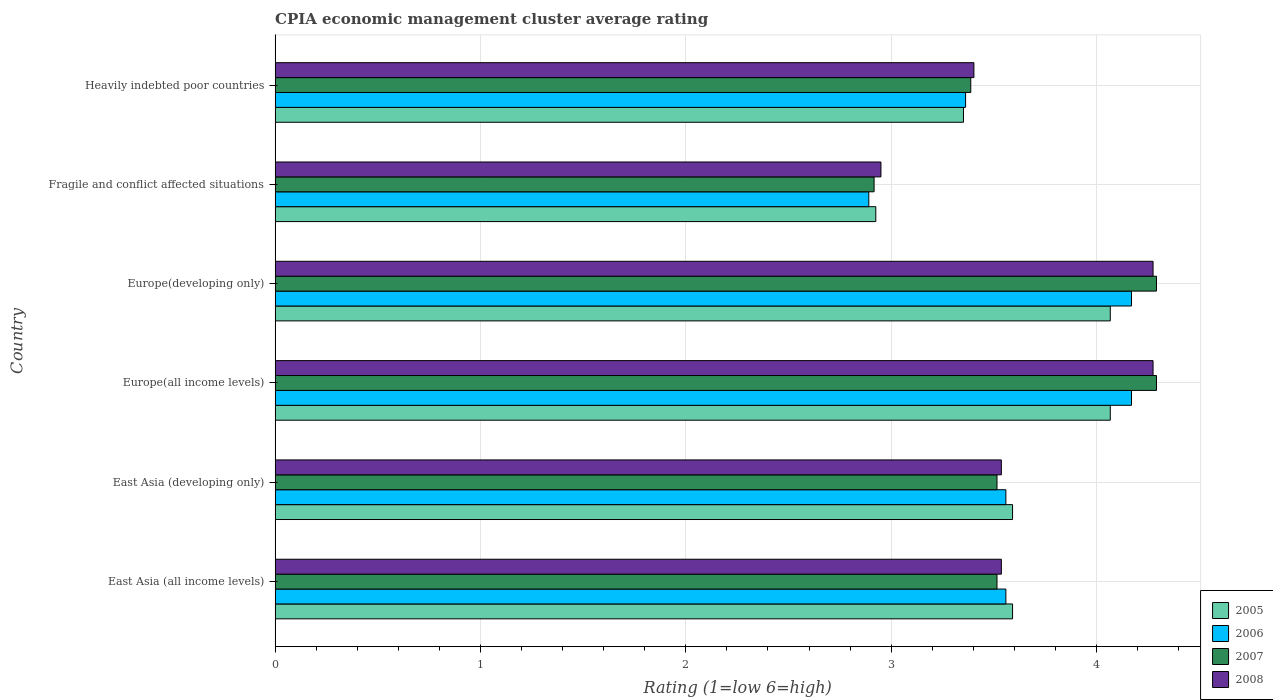How many groups of bars are there?
Offer a very short reply. 6. Are the number of bars per tick equal to the number of legend labels?
Provide a succinct answer. Yes. Are the number of bars on each tick of the Y-axis equal?
Provide a short and direct response. Yes. How many bars are there on the 1st tick from the bottom?
Keep it short and to the point. 4. What is the label of the 6th group of bars from the top?
Give a very brief answer. East Asia (all income levels). In how many cases, is the number of bars for a given country not equal to the number of legend labels?
Give a very brief answer. 0. What is the CPIA rating in 2008 in Fragile and conflict affected situations?
Make the answer very short. 2.95. Across all countries, what is the maximum CPIA rating in 2008?
Offer a terse response. 4.28. Across all countries, what is the minimum CPIA rating in 2005?
Provide a succinct answer. 2.92. In which country was the CPIA rating in 2006 maximum?
Offer a terse response. Europe(all income levels). In which country was the CPIA rating in 2008 minimum?
Provide a succinct answer. Fragile and conflict affected situations. What is the total CPIA rating in 2008 in the graph?
Give a very brief answer. 21.98. What is the difference between the CPIA rating in 2007 in East Asia (all income levels) and that in Fragile and conflict affected situations?
Your answer should be compact. 0.6. What is the difference between the CPIA rating in 2005 in Heavily indebted poor countries and the CPIA rating in 2006 in East Asia (developing only)?
Ensure brevity in your answer.  -0.21. What is the average CPIA rating in 2007 per country?
Your response must be concise. 3.65. What is the difference between the CPIA rating in 2008 and CPIA rating in 2007 in Europe(all income levels)?
Make the answer very short. -0.02. In how many countries, is the CPIA rating in 2005 greater than 2.6 ?
Your answer should be very brief. 6. What is the ratio of the CPIA rating in 2007 in East Asia (all income levels) to that in Heavily indebted poor countries?
Provide a succinct answer. 1.04. Is the CPIA rating in 2007 in East Asia (all income levels) less than that in Fragile and conflict affected situations?
Provide a succinct answer. No. What is the difference between the highest and the lowest CPIA rating in 2005?
Your answer should be compact. 1.14. What does the 1st bar from the top in Heavily indebted poor countries represents?
Offer a terse response. 2008. Is it the case that in every country, the sum of the CPIA rating in 2007 and CPIA rating in 2005 is greater than the CPIA rating in 2006?
Provide a succinct answer. Yes. Are all the bars in the graph horizontal?
Offer a terse response. Yes. How many countries are there in the graph?
Your answer should be very brief. 6. Does the graph contain any zero values?
Keep it short and to the point. No. Where does the legend appear in the graph?
Give a very brief answer. Bottom right. How are the legend labels stacked?
Offer a terse response. Vertical. What is the title of the graph?
Your answer should be compact. CPIA economic management cluster average rating. What is the Rating (1=low 6=high) of 2005 in East Asia (all income levels)?
Give a very brief answer. 3.59. What is the Rating (1=low 6=high) of 2006 in East Asia (all income levels)?
Make the answer very short. 3.56. What is the Rating (1=low 6=high) in 2007 in East Asia (all income levels)?
Give a very brief answer. 3.52. What is the Rating (1=low 6=high) of 2008 in East Asia (all income levels)?
Ensure brevity in your answer.  3.54. What is the Rating (1=low 6=high) in 2005 in East Asia (developing only)?
Your answer should be compact. 3.59. What is the Rating (1=low 6=high) of 2006 in East Asia (developing only)?
Your answer should be very brief. 3.56. What is the Rating (1=low 6=high) in 2007 in East Asia (developing only)?
Make the answer very short. 3.52. What is the Rating (1=low 6=high) of 2008 in East Asia (developing only)?
Your answer should be very brief. 3.54. What is the Rating (1=low 6=high) in 2005 in Europe(all income levels)?
Ensure brevity in your answer.  4.07. What is the Rating (1=low 6=high) in 2006 in Europe(all income levels)?
Provide a short and direct response. 4.17. What is the Rating (1=low 6=high) in 2007 in Europe(all income levels)?
Your response must be concise. 4.29. What is the Rating (1=low 6=high) in 2008 in Europe(all income levels)?
Offer a very short reply. 4.28. What is the Rating (1=low 6=high) of 2005 in Europe(developing only)?
Keep it short and to the point. 4.07. What is the Rating (1=low 6=high) in 2006 in Europe(developing only)?
Keep it short and to the point. 4.17. What is the Rating (1=low 6=high) of 2007 in Europe(developing only)?
Your answer should be very brief. 4.29. What is the Rating (1=low 6=high) in 2008 in Europe(developing only)?
Offer a terse response. 4.28. What is the Rating (1=low 6=high) in 2005 in Fragile and conflict affected situations?
Keep it short and to the point. 2.92. What is the Rating (1=low 6=high) in 2006 in Fragile and conflict affected situations?
Your answer should be compact. 2.89. What is the Rating (1=low 6=high) in 2007 in Fragile and conflict affected situations?
Offer a terse response. 2.92. What is the Rating (1=low 6=high) in 2008 in Fragile and conflict affected situations?
Ensure brevity in your answer.  2.95. What is the Rating (1=low 6=high) in 2005 in Heavily indebted poor countries?
Ensure brevity in your answer.  3.35. What is the Rating (1=low 6=high) in 2006 in Heavily indebted poor countries?
Make the answer very short. 3.36. What is the Rating (1=low 6=high) of 2007 in Heavily indebted poor countries?
Keep it short and to the point. 3.39. What is the Rating (1=low 6=high) in 2008 in Heavily indebted poor countries?
Make the answer very short. 3.4. Across all countries, what is the maximum Rating (1=low 6=high) of 2005?
Give a very brief answer. 4.07. Across all countries, what is the maximum Rating (1=low 6=high) of 2006?
Make the answer very short. 4.17. Across all countries, what is the maximum Rating (1=low 6=high) in 2007?
Your response must be concise. 4.29. Across all countries, what is the maximum Rating (1=low 6=high) of 2008?
Provide a succinct answer. 4.28. Across all countries, what is the minimum Rating (1=low 6=high) of 2005?
Keep it short and to the point. 2.92. Across all countries, what is the minimum Rating (1=low 6=high) in 2006?
Keep it short and to the point. 2.89. Across all countries, what is the minimum Rating (1=low 6=high) of 2007?
Offer a terse response. 2.92. Across all countries, what is the minimum Rating (1=low 6=high) in 2008?
Your answer should be very brief. 2.95. What is the total Rating (1=low 6=high) of 2005 in the graph?
Give a very brief answer. 21.59. What is the total Rating (1=low 6=high) of 2006 in the graph?
Provide a succinct answer. 21.71. What is the total Rating (1=low 6=high) of 2007 in the graph?
Offer a very short reply. 21.92. What is the total Rating (1=low 6=high) of 2008 in the graph?
Provide a short and direct response. 21.98. What is the difference between the Rating (1=low 6=high) in 2007 in East Asia (all income levels) and that in East Asia (developing only)?
Keep it short and to the point. 0. What is the difference between the Rating (1=low 6=high) of 2005 in East Asia (all income levels) and that in Europe(all income levels)?
Your response must be concise. -0.48. What is the difference between the Rating (1=low 6=high) in 2006 in East Asia (all income levels) and that in Europe(all income levels)?
Provide a short and direct response. -0.61. What is the difference between the Rating (1=low 6=high) in 2007 in East Asia (all income levels) and that in Europe(all income levels)?
Keep it short and to the point. -0.78. What is the difference between the Rating (1=low 6=high) of 2008 in East Asia (all income levels) and that in Europe(all income levels)?
Give a very brief answer. -0.74. What is the difference between the Rating (1=low 6=high) in 2005 in East Asia (all income levels) and that in Europe(developing only)?
Provide a succinct answer. -0.48. What is the difference between the Rating (1=low 6=high) of 2006 in East Asia (all income levels) and that in Europe(developing only)?
Offer a very short reply. -0.61. What is the difference between the Rating (1=low 6=high) of 2007 in East Asia (all income levels) and that in Europe(developing only)?
Make the answer very short. -0.78. What is the difference between the Rating (1=low 6=high) in 2008 in East Asia (all income levels) and that in Europe(developing only)?
Make the answer very short. -0.74. What is the difference between the Rating (1=low 6=high) in 2005 in East Asia (all income levels) and that in Fragile and conflict affected situations?
Offer a very short reply. 0.67. What is the difference between the Rating (1=low 6=high) in 2006 in East Asia (all income levels) and that in Fragile and conflict affected situations?
Offer a terse response. 0.67. What is the difference between the Rating (1=low 6=high) in 2007 in East Asia (all income levels) and that in Fragile and conflict affected situations?
Offer a very short reply. 0.6. What is the difference between the Rating (1=low 6=high) of 2008 in East Asia (all income levels) and that in Fragile and conflict affected situations?
Your answer should be very brief. 0.59. What is the difference between the Rating (1=low 6=high) in 2005 in East Asia (all income levels) and that in Heavily indebted poor countries?
Give a very brief answer. 0.24. What is the difference between the Rating (1=low 6=high) in 2006 in East Asia (all income levels) and that in Heavily indebted poor countries?
Give a very brief answer. 0.2. What is the difference between the Rating (1=low 6=high) in 2007 in East Asia (all income levels) and that in Heavily indebted poor countries?
Provide a short and direct response. 0.13. What is the difference between the Rating (1=low 6=high) in 2008 in East Asia (all income levels) and that in Heavily indebted poor countries?
Offer a very short reply. 0.13. What is the difference between the Rating (1=low 6=high) in 2005 in East Asia (developing only) and that in Europe(all income levels)?
Give a very brief answer. -0.48. What is the difference between the Rating (1=low 6=high) in 2006 in East Asia (developing only) and that in Europe(all income levels)?
Give a very brief answer. -0.61. What is the difference between the Rating (1=low 6=high) of 2007 in East Asia (developing only) and that in Europe(all income levels)?
Give a very brief answer. -0.78. What is the difference between the Rating (1=low 6=high) in 2008 in East Asia (developing only) and that in Europe(all income levels)?
Provide a succinct answer. -0.74. What is the difference between the Rating (1=low 6=high) in 2005 in East Asia (developing only) and that in Europe(developing only)?
Provide a short and direct response. -0.48. What is the difference between the Rating (1=low 6=high) in 2006 in East Asia (developing only) and that in Europe(developing only)?
Offer a very short reply. -0.61. What is the difference between the Rating (1=low 6=high) of 2007 in East Asia (developing only) and that in Europe(developing only)?
Your response must be concise. -0.78. What is the difference between the Rating (1=low 6=high) of 2008 in East Asia (developing only) and that in Europe(developing only)?
Keep it short and to the point. -0.74. What is the difference between the Rating (1=low 6=high) of 2005 in East Asia (developing only) and that in Fragile and conflict affected situations?
Offer a terse response. 0.67. What is the difference between the Rating (1=low 6=high) in 2006 in East Asia (developing only) and that in Fragile and conflict affected situations?
Give a very brief answer. 0.67. What is the difference between the Rating (1=low 6=high) of 2007 in East Asia (developing only) and that in Fragile and conflict affected situations?
Your response must be concise. 0.6. What is the difference between the Rating (1=low 6=high) in 2008 in East Asia (developing only) and that in Fragile and conflict affected situations?
Offer a terse response. 0.59. What is the difference between the Rating (1=low 6=high) of 2005 in East Asia (developing only) and that in Heavily indebted poor countries?
Offer a very short reply. 0.24. What is the difference between the Rating (1=low 6=high) of 2006 in East Asia (developing only) and that in Heavily indebted poor countries?
Offer a terse response. 0.2. What is the difference between the Rating (1=low 6=high) in 2007 in East Asia (developing only) and that in Heavily indebted poor countries?
Make the answer very short. 0.13. What is the difference between the Rating (1=low 6=high) in 2008 in East Asia (developing only) and that in Heavily indebted poor countries?
Your answer should be very brief. 0.13. What is the difference between the Rating (1=low 6=high) of 2006 in Europe(all income levels) and that in Europe(developing only)?
Offer a very short reply. 0. What is the difference between the Rating (1=low 6=high) of 2005 in Europe(all income levels) and that in Fragile and conflict affected situations?
Offer a terse response. 1.14. What is the difference between the Rating (1=low 6=high) in 2006 in Europe(all income levels) and that in Fragile and conflict affected situations?
Offer a very short reply. 1.28. What is the difference between the Rating (1=low 6=high) in 2007 in Europe(all income levels) and that in Fragile and conflict affected situations?
Your response must be concise. 1.38. What is the difference between the Rating (1=low 6=high) in 2008 in Europe(all income levels) and that in Fragile and conflict affected situations?
Your answer should be very brief. 1.32. What is the difference between the Rating (1=low 6=high) in 2005 in Europe(all income levels) and that in Heavily indebted poor countries?
Your response must be concise. 0.71. What is the difference between the Rating (1=low 6=high) of 2006 in Europe(all income levels) and that in Heavily indebted poor countries?
Your answer should be very brief. 0.81. What is the difference between the Rating (1=low 6=high) of 2007 in Europe(all income levels) and that in Heavily indebted poor countries?
Your response must be concise. 0.9. What is the difference between the Rating (1=low 6=high) of 2008 in Europe(all income levels) and that in Heavily indebted poor countries?
Offer a terse response. 0.87. What is the difference between the Rating (1=low 6=high) in 2005 in Europe(developing only) and that in Fragile and conflict affected situations?
Provide a succinct answer. 1.14. What is the difference between the Rating (1=low 6=high) of 2006 in Europe(developing only) and that in Fragile and conflict affected situations?
Provide a short and direct response. 1.28. What is the difference between the Rating (1=low 6=high) of 2007 in Europe(developing only) and that in Fragile and conflict affected situations?
Make the answer very short. 1.38. What is the difference between the Rating (1=low 6=high) in 2008 in Europe(developing only) and that in Fragile and conflict affected situations?
Give a very brief answer. 1.32. What is the difference between the Rating (1=low 6=high) of 2005 in Europe(developing only) and that in Heavily indebted poor countries?
Give a very brief answer. 0.71. What is the difference between the Rating (1=low 6=high) of 2006 in Europe(developing only) and that in Heavily indebted poor countries?
Provide a short and direct response. 0.81. What is the difference between the Rating (1=low 6=high) of 2007 in Europe(developing only) and that in Heavily indebted poor countries?
Offer a terse response. 0.9. What is the difference between the Rating (1=low 6=high) of 2008 in Europe(developing only) and that in Heavily indebted poor countries?
Keep it short and to the point. 0.87. What is the difference between the Rating (1=low 6=high) in 2005 in Fragile and conflict affected situations and that in Heavily indebted poor countries?
Give a very brief answer. -0.43. What is the difference between the Rating (1=low 6=high) in 2006 in Fragile and conflict affected situations and that in Heavily indebted poor countries?
Offer a terse response. -0.47. What is the difference between the Rating (1=low 6=high) in 2007 in Fragile and conflict affected situations and that in Heavily indebted poor countries?
Provide a short and direct response. -0.47. What is the difference between the Rating (1=low 6=high) in 2008 in Fragile and conflict affected situations and that in Heavily indebted poor countries?
Ensure brevity in your answer.  -0.45. What is the difference between the Rating (1=low 6=high) of 2005 in East Asia (all income levels) and the Rating (1=low 6=high) of 2006 in East Asia (developing only)?
Make the answer very short. 0.03. What is the difference between the Rating (1=low 6=high) in 2005 in East Asia (all income levels) and the Rating (1=low 6=high) in 2007 in East Asia (developing only)?
Provide a short and direct response. 0.08. What is the difference between the Rating (1=low 6=high) of 2005 in East Asia (all income levels) and the Rating (1=low 6=high) of 2008 in East Asia (developing only)?
Ensure brevity in your answer.  0.05. What is the difference between the Rating (1=low 6=high) of 2006 in East Asia (all income levels) and the Rating (1=low 6=high) of 2007 in East Asia (developing only)?
Make the answer very short. 0.04. What is the difference between the Rating (1=low 6=high) in 2006 in East Asia (all income levels) and the Rating (1=low 6=high) in 2008 in East Asia (developing only)?
Ensure brevity in your answer.  0.02. What is the difference between the Rating (1=low 6=high) in 2007 in East Asia (all income levels) and the Rating (1=low 6=high) in 2008 in East Asia (developing only)?
Your response must be concise. -0.02. What is the difference between the Rating (1=low 6=high) of 2005 in East Asia (all income levels) and the Rating (1=low 6=high) of 2006 in Europe(all income levels)?
Ensure brevity in your answer.  -0.58. What is the difference between the Rating (1=low 6=high) in 2005 in East Asia (all income levels) and the Rating (1=low 6=high) in 2007 in Europe(all income levels)?
Your response must be concise. -0.7. What is the difference between the Rating (1=low 6=high) in 2005 in East Asia (all income levels) and the Rating (1=low 6=high) in 2008 in Europe(all income levels)?
Keep it short and to the point. -0.68. What is the difference between the Rating (1=low 6=high) in 2006 in East Asia (all income levels) and the Rating (1=low 6=high) in 2007 in Europe(all income levels)?
Keep it short and to the point. -0.73. What is the difference between the Rating (1=low 6=high) of 2006 in East Asia (all income levels) and the Rating (1=low 6=high) of 2008 in Europe(all income levels)?
Your response must be concise. -0.72. What is the difference between the Rating (1=low 6=high) in 2007 in East Asia (all income levels) and the Rating (1=low 6=high) in 2008 in Europe(all income levels)?
Your response must be concise. -0.76. What is the difference between the Rating (1=low 6=high) in 2005 in East Asia (all income levels) and the Rating (1=low 6=high) in 2006 in Europe(developing only)?
Provide a short and direct response. -0.58. What is the difference between the Rating (1=low 6=high) in 2005 in East Asia (all income levels) and the Rating (1=low 6=high) in 2007 in Europe(developing only)?
Ensure brevity in your answer.  -0.7. What is the difference between the Rating (1=low 6=high) of 2005 in East Asia (all income levels) and the Rating (1=low 6=high) of 2008 in Europe(developing only)?
Your response must be concise. -0.68. What is the difference between the Rating (1=low 6=high) of 2006 in East Asia (all income levels) and the Rating (1=low 6=high) of 2007 in Europe(developing only)?
Your answer should be very brief. -0.73. What is the difference between the Rating (1=low 6=high) in 2006 in East Asia (all income levels) and the Rating (1=low 6=high) in 2008 in Europe(developing only)?
Provide a succinct answer. -0.72. What is the difference between the Rating (1=low 6=high) of 2007 in East Asia (all income levels) and the Rating (1=low 6=high) of 2008 in Europe(developing only)?
Offer a terse response. -0.76. What is the difference between the Rating (1=low 6=high) in 2005 in East Asia (all income levels) and the Rating (1=low 6=high) in 2007 in Fragile and conflict affected situations?
Give a very brief answer. 0.67. What is the difference between the Rating (1=low 6=high) in 2005 in East Asia (all income levels) and the Rating (1=low 6=high) in 2008 in Fragile and conflict affected situations?
Your response must be concise. 0.64. What is the difference between the Rating (1=low 6=high) of 2006 in East Asia (all income levels) and the Rating (1=low 6=high) of 2007 in Fragile and conflict affected situations?
Your response must be concise. 0.64. What is the difference between the Rating (1=low 6=high) of 2006 in East Asia (all income levels) and the Rating (1=low 6=high) of 2008 in Fragile and conflict affected situations?
Your answer should be very brief. 0.61. What is the difference between the Rating (1=low 6=high) in 2007 in East Asia (all income levels) and the Rating (1=low 6=high) in 2008 in Fragile and conflict affected situations?
Your response must be concise. 0.57. What is the difference between the Rating (1=low 6=high) of 2005 in East Asia (all income levels) and the Rating (1=low 6=high) of 2006 in Heavily indebted poor countries?
Make the answer very short. 0.23. What is the difference between the Rating (1=low 6=high) of 2005 in East Asia (all income levels) and the Rating (1=low 6=high) of 2007 in Heavily indebted poor countries?
Your answer should be very brief. 0.2. What is the difference between the Rating (1=low 6=high) of 2005 in East Asia (all income levels) and the Rating (1=low 6=high) of 2008 in Heavily indebted poor countries?
Your answer should be very brief. 0.19. What is the difference between the Rating (1=low 6=high) of 2006 in East Asia (all income levels) and the Rating (1=low 6=high) of 2007 in Heavily indebted poor countries?
Your answer should be compact. 0.17. What is the difference between the Rating (1=low 6=high) in 2006 in East Asia (all income levels) and the Rating (1=low 6=high) in 2008 in Heavily indebted poor countries?
Your answer should be compact. 0.16. What is the difference between the Rating (1=low 6=high) of 2007 in East Asia (all income levels) and the Rating (1=low 6=high) of 2008 in Heavily indebted poor countries?
Offer a terse response. 0.11. What is the difference between the Rating (1=low 6=high) of 2005 in East Asia (developing only) and the Rating (1=low 6=high) of 2006 in Europe(all income levels)?
Your answer should be very brief. -0.58. What is the difference between the Rating (1=low 6=high) in 2005 in East Asia (developing only) and the Rating (1=low 6=high) in 2007 in Europe(all income levels)?
Give a very brief answer. -0.7. What is the difference between the Rating (1=low 6=high) in 2005 in East Asia (developing only) and the Rating (1=low 6=high) in 2008 in Europe(all income levels)?
Make the answer very short. -0.68. What is the difference between the Rating (1=low 6=high) in 2006 in East Asia (developing only) and the Rating (1=low 6=high) in 2007 in Europe(all income levels)?
Your response must be concise. -0.73. What is the difference between the Rating (1=low 6=high) of 2006 in East Asia (developing only) and the Rating (1=low 6=high) of 2008 in Europe(all income levels)?
Provide a succinct answer. -0.72. What is the difference between the Rating (1=low 6=high) in 2007 in East Asia (developing only) and the Rating (1=low 6=high) in 2008 in Europe(all income levels)?
Offer a terse response. -0.76. What is the difference between the Rating (1=low 6=high) in 2005 in East Asia (developing only) and the Rating (1=low 6=high) in 2006 in Europe(developing only)?
Your answer should be compact. -0.58. What is the difference between the Rating (1=low 6=high) in 2005 in East Asia (developing only) and the Rating (1=low 6=high) in 2007 in Europe(developing only)?
Make the answer very short. -0.7. What is the difference between the Rating (1=low 6=high) of 2005 in East Asia (developing only) and the Rating (1=low 6=high) of 2008 in Europe(developing only)?
Your answer should be compact. -0.68. What is the difference between the Rating (1=low 6=high) of 2006 in East Asia (developing only) and the Rating (1=low 6=high) of 2007 in Europe(developing only)?
Make the answer very short. -0.73. What is the difference between the Rating (1=low 6=high) of 2006 in East Asia (developing only) and the Rating (1=low 6=high) of 2008 in Europe(developing only)?
Give a very brief answer. -0.72. What is the difference between the Rating (1=low 6=high) of 2007 in East Asia (developing only) and the Rating (1=low 6=high) of 2008 in Europe(developing only)?
Your answer should be compact. -0.76. What is the difference between the Rating (1=low 6=high) of 2005 in East Asia (developing only) and the Rating (1=low 6=high) of 2006 in Fragile and conflict affected situations?
Make the answer very short. 0.7. What is the difference between the Rating (1=low 6=high) of 2005 in East Asia (developing only) and the Rating (1=low 6=high) of 2007 in Fragile and conflict affected situations?
Give a very brief answer. 0.67. What is the difference between the Rating (1=low 6=high) in 2005 in East Asia (developing only) and the Rating (1=low 6=high) in 2008 in Fragile and conflict affected situations?
Offer a very short reply. 0.64. What is the difference between the Rating (1=low 6=high) in 2006 in East Asia (developing only) and the Rating (1=low 6=high) in 2007 in Fragile and conflict affected situations?
Your response must be concise. 0.64. What is the difference between the Rating (1=low 6=high) of 2006 in East Asia (developing only) and the Rating (1=low 6=high) of 2008 in Fragile and conflict affected situations?
Your answer should be very brief. 0.61. What is the difference between the Rating (1=low 6=high) in 2007 in East Asia (developing only) and the Rating (1=low 6=high) in 2008 in Fragile and conflict affected situations?
Your answer should be compact. 0.57. What is the difference between the Rating (1=low 6=high) of 2005 in East Asia (developing only) and the Rating (1=low 6=high) of 2006 in Heavily indebted poor countries?
Your answer should be compact. 0.23. What is the difference between the Rating (1=low 6=high) in 2005 in East Asia (developing only) and the Rating (1=low 6=high) in 2007 in Heavily indebted poor countries?
Keep it short and to the point. 0.2. What is the difference between the Rating (1=low 6=high) of 2005 in East Asia (developing only) and the Rating (1=low 6=high) of 2008 in Heavily indebted poor countries?
Provide a succinct answer. 0.19. What is the difference between the Rating (1=low 6=high) of 2006 in East Asia (developing only) and the Rating (1=low 6=high) of 2007 in Heavily indebted poor countries?
Your answer should be compact. 0.17. What is the difference between the Rating (1=low 6=high) in 2006 in East Asia (developing only) and the Rating (1=low 6=high) in 2008 in Heavily indebted poor countries?
Keep it short and to the point. 0.16. What is the difference between the Rating (1=low 6=high) of 2007 in East Asia (developing only) and the Rating (1=low 6=high) of 2008 in Heavily indebted poor countries?
Provide a short and direct response. 0.11. What is the difference between the Rating (1=low 6=high) in 2005 in Europe(all income levels) and the Rating (1=low 6=high) in 2006 in Europe(developing only)?
Offer a very short reply. -0.1. What is the difference between the Rating (1=low 6=high) of 2005 in Europe(all income levels) and the Rating (1=low 6=high) of 2007 in Europe(developing only)?
Provide a short and direct response. -0.23. What is the difference between the Rating (1=low 6=high) of 2005 in Europe(all income levels) and the Rating (1=low 6=high) of 2008 in Europe(developing only)?
Provide a short and direct response. -0.21. What is the difference between the Rating (1=low 6=high) of 2006 in Europe(all income levels) and the Rating (1=low 6=high) of 2007 in Europe(developing only)?
Provide a short and direct response. -0.12. What is the difference between the Rating (1=low 6=high) of 2006 in Europe(all income levels) and the Rating (1=low 6=high) of 2008 in Europe(developing only)?
Provide a succinct answer. -0.1. What is the difference between the Rating (1=low 6=high) of 2007 in Europe(all income levels) and the Rating (1=low 6=high) of 2008 in Europe(developing only)?
Make the answer very short. 0.02. What is the difference between the Rating (1=low 6=high) of 2005 in Europe(all income levels) and the Rating (1=low 6=high) of 2006 in Fragile and conflict affected situations?
Give a very brief answer. 1.18. What is the difference between the Rating (1=low 6=high) of 2005 in Europe(all income levels) and the Rating (1=low 6=high) of 2007 in Fragile and conflict affected situations?
Give a very brief answer. 1.15. What is the difference between the Rating (1=low 6=high) of 2005 in Europe(all income levels) and the Rating (1=low 6=high) of 2008 in Fragile and conflict affected situations?
Keep it short and to the point. 1.12. What is the difference between the Rating (1=low 6=high) in 2006 in Europe(all income levels) and the Rating (1=low 6=high) in 2007 in Fragile and conflict affected situations?
Your answer should be very brief. 1.25. What is the difference between the Rating (1=low 6=high) of 2006 in Europe(all income levels) and the Rating (1=low 6=high) of 2008 in Fragile and conflict affected situations?
Provide a short and direct response. 1.22. What is the difference between the Rating (1=low 6=high) of 2007 in Europe(all income levels) and the Rating (1=low 6=high) of 2008 in Fragile and conflict affected situations?
Offer a terse response. 1.34. What is the difference between the Rating (1=low 6=high) of 2005 in Europe(all income levels) and the Rating (1=low 6=high) of 2006 in Heavily indebted poor countries?
Your response must be concise. 0.7. What is the difference between the Rating (1=low 6=high) in 2005 in Europe(all income levels) and the Rating (1=low 6=high) in 2007 in Heavily indebted poor countries?
Your answer should be compact. 0.68. What is the difference between the Rating (1=low 6=high) in 2005 in Europe(all income levels) and the Rating (1=low 6=high) in 2008 in Heavily indebted poor countries?
Your answer should be very brief. 0.66. What is the difference between the Rating (1=low 6=high) of 2006 in Europe(all income levels) and the Rating (1=low 6=high) of 2007 in Heavily indebted poor countries?
Offer a very short reply. 0.78. What is the difference between the Rating (1=low 6=high) of 2006 in Europe(all income levels) and the Rating (1=low 6=high) of 2008 in Heavily indebted poor countries?
Give a very brief answer. 0.77. What is the difference between the Rating (1=low 6=high) of 2007 in Europe(all income levels) and the Rating (1=low 6=high) of 2008 in Heavily indebted poor countries?
Offer a terse response. 0.89. What is the difference between the Rating (1=low 6=high) of 2005 in Europe(developing only) and the Rating (1=low 6=high) of 2006 in Fragile and conflict affected situations?
Your answer should be very brief. 1.18. What is the difference between the Rating (1=low 6=high) of 2005 in Europe(developing only) and the Rating (1=low 6=high) of 2007 in Fragile and conflict affected situations?
Give a very brief answer. 1.15. What is the difference between the Rating (1=low 6=high) in 2005 in Europe(developing only) and the Rating (1=low 6=high) in 2008 in Fragile and conflict affected situations?
Offer a terse response. 1.12. What is the difference between the Rating (1=low 6=high) of 2006 in Europe(developing only) and the Rating (1=low 6=high) of 2007 in Fragile and conflict affected situations?
Give a very brief answer. 1.25. What is the difference between the Rating (1=low 6=high) of 2006 in Europe(developing only) and the Rating (1=low 6=high) of 2008 in Fragile and conflict affected situations?
Provide a short and direct response. 1.22. What is the difference between the Rating (1=low 6=high) of 2007 in Europe(developing only) and the Rating (1=low 6=high) of 2008 in Fragile and conflict affected situations?
Offer a terse response. 1.34. What is the difference between the Rating (1=low 6=high) in 2005 in Europe(developing only) and the Rating (1=low 6=high) in 2006 in Heavily indebted poor countries?
Keep it short and to the point. 0.7. What is the difference between the Rating (1=low 6=high) in 2005 in Europe(developing only) and the Rating (1=low 6=high) in 2007 in Heavily indebted poor countries?
Make the answer very short. 0.68. What is the difference between the Rating (1=low 6=high) of 2005 in Europe(developing only) and the Rating (1=low 6=high) of 2008 in Heavily indebted poor countries?
Make the answer very short. 0.66. What is the difference between the Rating (1=low 6=high) in 2006 in Europe(developing only) and the Rating (1=low 6=high) in 2007 in Heavily indebted poor countries?
Your response must be concise. 0.78. What is the difference between the Rating (1=low 6=high) in 2006 in Europe(developing only) and the Rating (1=low 6=high) in 2008 in Heavily indebted poor countries?
Your response must be concise. 0.77. What is the difference between the Rating (1=low 6=high) in 2007 in Europe(developing only) and the Rating (1=low 6=high) in 2008 in Heavily indebted poor countries?
Provide a short and direct response. 0.89. What is the difference between the Rating (1=low 6=high) of 2005 in Fragile and conflict affected situations and the Rating (1=low 6=high) of 2006 in Heavily indebted poor countries?
Give a very brief answer. -0.44. What is the difference between the Rating (1=low 6=high) of 2005 in Fragile and conflict affected situations and the Rating (1=low 6=high) of 2007 in Heavily indebted poor countries?
Offer a terse response. -0.46. What is the difference between the Rating (1=low 6=high) in 2005 in Fragile and conflict affected situations and the Rating (1=low 6=high) in 2008 in Heavily indebted poor countries?
Ensure brevity in your answer.  -0.48. What is the difference between the Rating (1=low 6=high) of 2006 in Fragile and conflict affected situations and the Rating (1=low 6=high) of 2007 in Heavily indebted poor countries?
Provide a short and direct response. -0.5. What is the difference between the Rating (1=low 6=high) of 2006 in Fragile and conflict affected situations and the Rating (1=low 6=high) of 2008 in Heavily indebted poor countries?
Your answer should be compact. -0.51. What is the difference between the Rating (1=low 6=high) of 2007 in Fragile and conflict affected situations and the Rating (1=low 6=high) of 2008 in Heavily indebted poor countries?
Offer a very short reply. -0.49. What is the average Rating (1=low 6=high) of 2005 per country?
Offer a very short reply. 3.6. What is the average Rating (1=low 6=high) in 2006 per country?
Give a very brief answer. 3.62. What is the average Rating (1=low 6=high) of 2007 per country?
Give a very brief answer. 3.65. What is the average Rating (1=low 6=high) in 2008 per country?
Provide a succinct answer. 3.66. What is the difference between the Rating (1=low 6=high) in 2005 and Rating (1=low 6=high) in 2006 in East Asia (all income levels)?
Your response must be concise. 0.03. What is the difference between the Rating (1=low 6=high) of 2005 and Rating (1=low 6=high) of 2007 in East Asia (all income levels)?
Ensure brevity in your answer.  0.08. What is the difference between the Rating (1=low 6=high) of 2005 and Rating (1=low 6=high) of 2008 in East Asia (all income levels)?
Your response must be concise. 0.05. What is the difference between the Rating (1=low 6=high) in 2006 and Rating (1=low 6=high) in 2007 in East Asia (all income levels)?
Your answer should be compact. 0.04. What is the difference between the Rating (1=low 6=high) of 2006 and Rating (1=low 6=high) of 2008 in East Asia (all income levels)?
Make the answer very short. 0.02. What is the difference between the Rating (1=low 6=high) of 2007 and Rating (1=low 6=high) of 2008 in East Asia (all income levels)?
Your response must be concise. -0.02. What is the difference between the Rating (1=low 6=high) in 2005 and Rating (1=low 6=high) in 2006 in East Asia (developing only)?
Your answer should be compact. 0.03. What is the difference between the Rating (1=low 6=high) of 2005 and Rating (1=low 6=high) of 2007 in East Asia (developing only)?
Offer a very short reply. 0.08. What is the difference between the Rating (1=low 6=high) in 2005 and Rating (1=low 6=high) in 2008 in East Asia (developing only)?
Give a very brief answer. 0.05. What is the difference between the Rating (1=low 6=high) of 2006 and Rating (1=low 6=high) of 2007 in East Asia (developing only)?
Give a very brief answer. 0.04. What is the difference between the Rating (1=low 6=high) of 2006 and Rating (1=low 6=high) of 2008 in East Asia (developing only)?
Offer a very short reply. 0.02. What is the difference between the Rating (1=low 6=high) of 2007 and Rating (1=low 6=high) of 2008 in East Asia (developing only)?
Your response must be concise. -0.02. What is the difference between the Rating (1=low 6=high) in 2005 and Rating (1=low 6=high) in 2006 in Europe(all income levels)?
Your answer should be very brief. -0.1. What is the difference between the Rating (1=low 6=high) of 2005 and Rating (1=low 6=high) of 2007 in Europe(all income levels)?
Your answer should be very brief. -0.23. What is the difference between the Rating (1=low 6=high) of 2005 and Rating (1=low 6=high) of 2008 in Europe(all income levels)?
Your answer should be compact. -0.21. What is the difference between the Rating (1=low 6=high) in 2006 and Rating (1=low 6=high) in 2007 in Europe(all income levels)?
Offer a terse response. -0.12. What is the difference between the Rating (1=low 6=high) of 2006 and Rating (1=low 6=high) of 2008 in Europe(all income levels)?
Keep it short and to the point. -0.1. What is the difference between the Rating (1=low 6=high) in 2007 and Rating (1=low 6=high) in 2008 in Europe(all income levels)?
Offer a very short reply. 0.02. What is the difference between the Rating (1=low 6=high) of 2005 and Rating (1=low 6=high) of 2006 in Europe(developing only)?
Give a very brief answer. -0.1. What is the difference between the Rating (1=low 6=high) in 2005 and Rating (1=low 6=high) in 2007 in Europe(developing only)?
Your answer should be compact. -0.23. What is the difference between the Rating (1=low 6=high) in 2005 and Rating (1=low 6=high) in 2008 in Europe(developing only)?
Your response must be concise. -0.21. What is the difference between the Rating (1=low 6=high) in 2006 and Rating (1=low 6=high) in 2007 in Europe(developing only)?
Offer a very short reply. -0.12. What is the difference between the Rating (1=low 6=high) of 2006 and Rating (1=low 6=high) of 2008 in Europe(developing only)?
Ensure brevity in your answer.  -0.1. What is the difference between the Rating (1=low 6=high) in 2007 and Rating (1=low 6=high) in 2008 in Europe(developing only)?
Make the answer very short. 0.02. What is the difference between the Rating (1=low 6=high) in 2005 and Rating (1=low 6=high) in 2006 in Fragile and conflict affected situations?
Ensure brevity in your answer.  0.03. What is the difference between the Rating (1=low 6=high) of 2005 and Rating (1=low 6=high) of 2007 in Fragile and conflict affected situations?
Your answer should be compact. 0.01. What is the difference between the Rating (1=low 6=high) of 2005 and Rating (1=low 6=high) of 2008 in Fragile and conflict affected situations?
Your answer should be very brief. -0.03. What is the difference between the Rating (1=low 6=high) of 2006 and Rating (1=low 6=high) of 2007 in Fragile and conflict affected situations?
Your answer should be compact. -0.03. What is the difference between the Rating (1=low 6=high) in 2006 and Rating (1=low 6=high) in 2008 in Fragile and conflict affected situations?
Provide a succinct answer. -0.06. What is the difference between the Rating (1=low 6=high) of 2007 and Rating (1=low 6=high) of 2008 in Fragile and conflict affected situations?
Your response must be concise. -0.03. What is the difference between the Rating (1=low 6=high) in 2005 and Rating (1=low 6=high) in 2006 in Heavily indebted poor countries?
Your answer should be compact. -0.01. What is the difference between the Rating (1=low 6=high) of 2005 and Rating (1=low 6=high) of 2007 in Heavily indebted poor countries?
Your answer should be compact. -0.04. What is the difference between the Rating (1=low 6=high) in 2005 and Rating (1=low 6=high) in 2008 in Heavily indebted poor countries?
Offer a terse response. -0.05. What is the difference between the Rating (1=low 6=high) in 2006 and Rating (1=low 6=high) in 2007 in Heavily indebted poor countries?
Ensure brevity in your answer.  -0.03. What is the difference between the Rating (1=low 6=high) in 2006 and Rating (1=low 6=high) in 2008 in Heavily indebted poor countries?
Your answer should be very brief. -0.04. What is the difference between the Rating (1=low 6=high) of 2007 and Rating (1=low 6=high) of 2008 in Heavily indebted poor countries?
Your response must be concise. -0.02. What is the ratio of the Rating (1=low 6=high) of 2005 in East Asia (all income levels) to that in East Asia (developing only)?
Offer a terse response. 1. What is the ratio of the Rating (1=low 6=high) in 2006 in East Asia (all income levels) to that in East Asia (developing only)?
Offer a terse response. 1. What is the ratio of the Rating (1=low 6=high) in 2005 in East Asia (all income levels) to that in Europe(all income levels)?
Ensure brevity in your answer.  0.88. What is the ratio of the Rating (1=low 6=high) of 2006 in East Asia (all income levels) to that in Europe(all income levels)?
Offer a terse response. 0.85. What is the ratio of the Rating (1=low 6=high) in 2007 in East Asia (all income levels) to that in Europe(all income levels)?
Provide a succinct answer. 0.82. What is the ratio of the Rating (1=low 6=high) of 2008 in East Asia (all income levels) to that in Europe(all income levels)?
Ensure brevity in your answer.  0.83. What is the ratio of the Rating (1=low 6=high) in 2005 in East Asia (all income levels) to that in Europe(developing only)?
Offer a terse response. 0.88. What is the ratio of the Rating (1=low 6=high) in 2006 in East Asia (all income levels) to that in Europe(developing only)?
Provide a short and direct response. 0.85. What is the ratio of the Rating (1=low 6=high) of 2007 in East Asia (all income levels) to that in Europe(developing only)?
Ensure brevity in your answer.  0.82. What is the ratio of the Rating (1=low 6=high) in 2008 in East Asia (all income levels) to that in Europe(developing only)?
Your answer should be very brief. 0.83. What is the ratio of the Rating (1=low 6=high) in 2005 in East Asia (all income levels) to that in Fragile and conflict affected situations?
Make the answer very short. 1.23. What is the ratio of the Rating (1=low 6=high) in 2006 in East Asia (all income levels) to that in Fragile and conflict affected situations?
Offer a very short reply. 1.23. What is the ratio of the Rating (1=low 6=high) in 2007 in East Asia (all income levels) to that in Fragile and conflict affected situations?
Your response must be concise. 1.21. What is the ratio of the Rating (1=low 6=high) of 2008 in East Asia (all income levels) to that in Fragile and conflict affected situations?
Provide a short and direct response. 1.2. What is the ratio of the Rating (1=low 6=high) in 2005 in East Asia (all income levels) to that in Heavily indebted poor countries?
Your answer should be compact. 1.07. What is the ratio of the Rating (1=low 6=high) of 2006 in East Asia (all income levels) to that in Heavily indebted poor countries?
Make the answer very short. 1.06. What is the ratio of the Rating (1=low 6=high) of 2007 in East Asia (all income levels) to that in Heavily indebted poor countries?
Your answer should be compact. 1.04. What is the ratio of the Rating (1=low 6=high) of 2008 in East Asia (all income levels) to that in Heavily indebted poor countries?
Offer a terse response. 1.04. What is the ratio of the Rating (1=low 6=high) in 2005 in East Asia (developing only) to that in Europe(all income levels)?
Your answer should be very brief. 0.88. What is the ratio of the Rating (1=low 6=high) of 2006 in East Asia (developing only) to that in Europe(all income levels)?
Give a very brief answer. 0.85. What is the ratio of the Rating (1=low 6=high) of 2007 in East Asia (developing only) to that in Europe(all income levels)?
Your response must be concise. 0.82. What is the ratio of the Rating (1=low 6=high) in 2008 in East Asia (developing only) to that in Europe(all income levels)?
Make the answer very short. 0.83. What is the ratio of the Rating (1=low 6=high) in 2005 in East Asia (developing only) to that in Europe(developing only)?
Offer a very short reply. 0.88. What is the ratio of the Rating (1=low 6=high) in 2006 in East Asia (developing only) to that in Europe(developing only)?
Make the answer very short. 0.85. What is the ratio of the Rating (1=low 6=high) in 2007 in East Asia (developing only) to that in Europe(developing only)?
Offer a very short reply. 0.82. What is the ratio of the Rating (1=low 6=high) of 2008 in East Asia (developing only) to that in Europe(developing only)?
Offer a very short reply. 0.83. What is the ratio of the Rating (1=low 6=high) of 2005 in East Asia (developing only) to that in Fragile and conflict affected situations?
Your answer should be very brief. 1.23. What is the ratio of the Rating (1=low 6=high) of 2006 in East Asia (developing only) to that in Fragile and conflict affected situations?
Give a very brief answer. 1.23. What is the ratio of the Rating (1=low 6=high) in 2007 in East Asia (developing only) to that in Fragile and conflict affected situations?
Your response must be concise. 1.21. What is the ratio of the Rating (1=low 6=high) in 2008 in East Asia (developing only) to that in Fragile and conflict affected situations?
Your answer should be compact. 1.2. What is the ratio of the Rating (1=low 6=high) in 2005 in East Asia (developing only) to that in Heavily indebted poor countries?
Your answer should be compact. 1.07. What is the ratio of the Rating (1=low 6=high) of 2006 in East Asia (developing only) to that in Heavily indebted poor countries?
Provide a short and direct response. 1.06. What is the ratio of the Rating (1=low 6=high) in 2007 in East Asia (developing only) to that in Heavily indebted poor countries?
Your answer should be very brief. 1.04. What is the ratio of the Rating (1=low 6=high) in 2008 in East Asia (developing only) to that in Heavily indebted poor countries?
Your response must be concise. 1.04. What is the ratio of the Rating (1=low 6=high) of 2007 in Europe(all income levels) to that in Europe(developing only)?
Offer a terse response. 1. What is the ratio of the Rating (1=low 6=high) of 2008 in Europe(all income levels) to that in Europe(developing only)?
Keep it short and to the point. 1. What is the ratio of the Rating (1=low 6=high) of 2005 in Europe(all income levels) to that in Fragile and conflict affected situations?
Keep it short and to the point. 1.39. What is the ratio of the Rating (1=low 6=high) in 2006 in Europe(all income levels) to that in Fragile and conflict affected situations?
Make the answer very short. 1.44. What is the ratio of the Rating (1=low 6=high) in 2007 in Europe(all income levels) to that in Fragile and conflict affected situations?
Make the answer very short. 1.47. What is the ratio of the Rating (1=low 6=high) of 2008 in Europe(all income levels) to that in Fragile and conflict affected situations?
Provide a short and direct response. 1.45. What is the ratio of the Rating (1=low 6=high) of 2005 in Europe(all income levels) to that in Heavily indebted poor countries?
Ensure brevity in your answer.  1.21. What is the ratio of the Rating (1=low 6=high) of 2006 in Europe(all income levels) to that in Heavily indebted poor countries?
Your answer should be compact. 1.24. What is the ratio of the Rating (1=low 6=high) of 2007 in Europe(all income levels) to that in Heavily indebted poor countries?
Ensure brevity in your answer.  1.27. What is the ratio of the Rating (1=low 6=high) of 2008 in Europe(all income levels) to that in Heavily indebted poor countries?
Your answer should be compact. 1.26. What is the ratio of the Rating (1=low 6=high) in 2005 in Europe(developing only) to that in Fragile and conflict affected situations?
Make the answer very short. 1.39. What is the ratio of the Rating (1=low 6=high) in 2006 in Europe(developing only) to that in Fragile and conflict affected situations?
Provide a succinct answer. 1.44. What is the ratio of the Rating (1=low 6=high) of 2007 in Europe(developing only) to that in Fragile and conflict affected situations?
Give a very brief answer. 1.47. What is the ratio of the Rating (1=low 6=high) of 2008 in Europe(developing only) to that in Fragile and conflict affected situations?
Offer a very short reply. 1.45. What is the ratio of the Rating (1=low 6=high) of 2005 in Europe(developing only) to that in Heavily indebted poor countries?
Offer a very short reply. 1.21. What is the ratio of the Rating (1=low 6=high) in 2006 in Europe(developing only) to that in Heavily indebted poor countries?
Your answer should be compact. 1.24. What is the ratio of the Rating (1=low 6=high) of 2007 in Europe(developing only) to that in Heavily indebted poor countries?
Make the answer very short. 1.27. What is the ratio of the Rating (1=low 6=high) in 2008 in Europe(developing only) to that in Heavily indebted poor countries?
Your response must be concise. 1.26. What is the ratio of the Rating (1=low 6=high) of 2005 in Fragile and conflict affected situations to that in Heavily indebted poor countries?
Your answer should be very brief. 0.87. What is the ratio of the Rating (1=low 6=high) of 2006 in Fragile and conflict affected situations to that in Heavily indebted poor countries?
Make the answer very short. 0.86. What is the ratio of the Rating (1=low 6=high) in 2007 in Fragile and conflict affected situations to that in Heavily indebted poor countries?
Offer a terse response. 0.86. What is the ratio of the Rating (1=low 6=high) in 2008 in Fragile and conflict affected situations to that in Heavily indebted poor countries?
Offer a very short reply. 0.87. What is the difference between the highest and the second highest Rating (1=low 6=high) in 2006?
Provide a succinct answer. 0. What is the difference between the highest and the second highest Rating (1=low 6=high) in 2007?
Make the answer very short. 0. What is the difference between the highest and the second highest Rating (1=low 6=high) of 2008?
Offer a very short reply. 0. What is the difference between the highest and the lowest Rating (1=low 6=high) of 2005?
Provide a short and direct response. 1.14. What is the difference between the highest and the lowest Rating (1=low 6=high) in 2006?
Give a very brief answer. 1.28. What is the difference between the highest and the lowest Rating (1=low 6=high) of 2007?
Your response must be concise. 1.38. What is the difference between the highest and the lowest Rating (1=low 6=high) in 2008?
Offer a terse response. 1.32. 